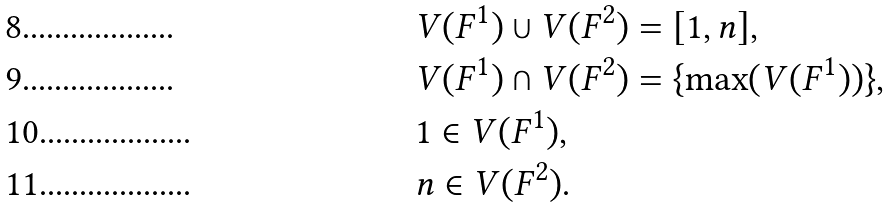<formula> <loc_0><loc_0><loc_500><loc_500>& V ( F ^ { 1 } ) \cup V ( F ^ { 2 } ) = [ 1 , n ] , \\ & V ( F ^ { 1 } ) \cap V ( F ^ { 2 } ) = \{ \max ( V ( F ^ { 1 } ) ) \} , \\ & 1 \in V ( F ^ { 1 } ) , \\ & n \in V ( F ^ { 2 } ) .</formula> 